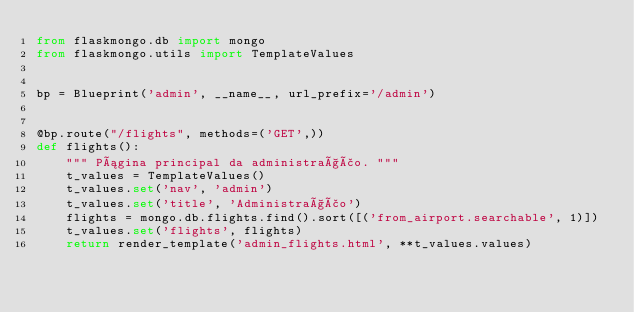<code> <loc_0><loc_0><loc_500><loc_500><_Python_>from flaskmongo.db import mongo
from flaskmongo.utils import TemplateValues


bp = Blueprint('admin', __name__, url_prefix='/admin')


@bp.route("/flights", methods=('GET',))
def flights():
    """ Página principal da administração. """
    t_values = TemplateValues()
    t_values.set('nav', 'admin')
    t_values.set('title', 'Administração')
    flights = mongo.db.flights.find().sort([('from_airport.searchable', 1)])
    t_values.set('flights', flights)
    return render_template('admin_flights.html', **t_values.values)</code> 